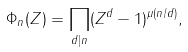Convert formula to latex. <formula><loc_0><loc_0><loc_500><loc_500>\Phi _ { n } ( Z ) = \prod _ { d | n } ( Z ^ { d } - 1 ) ^ { \mu ( n / d ) } ,</formula> 